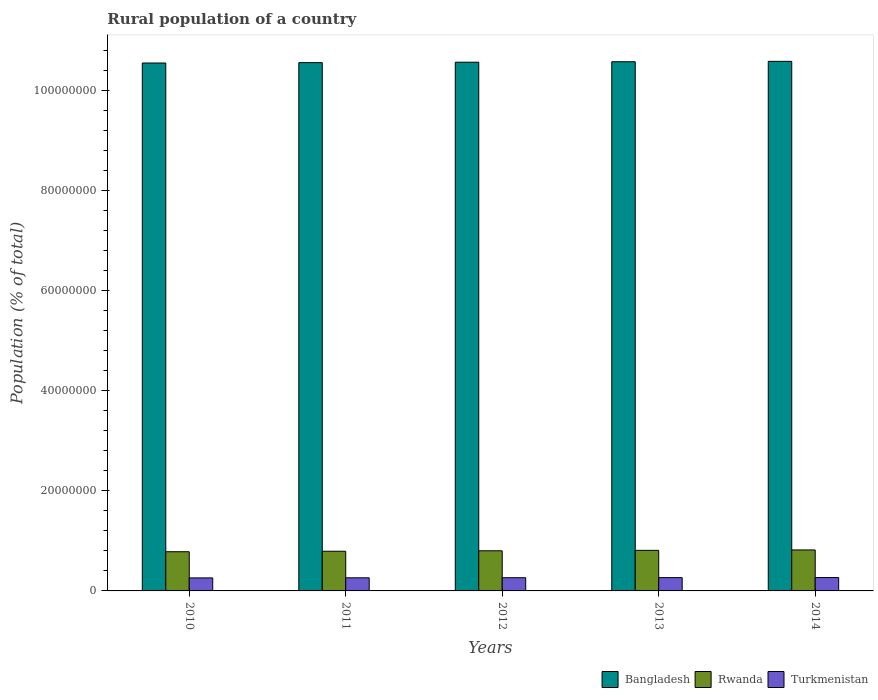How many different coloured bars are there?
Keep it short and to the point. 3. Are the number of bars per tick equal to the number of legend labels?
Your answer should be very brief. Yes. Are the number of bars on each tick of the X-axis equal?
Provide a succinct answer. Yes. How many bars are there on the 3rd tick from the left?
Give a very brief answer. 3. How many bars are there on the 1st tick from the right?
Provide a short and direct response. 3. What is the rural population in Turkmenistan in 2013?
Make the answer very short. 2.65e+06. Across all years, what is the maximum rural population in Turkmenistan?
Provide a short and direct response. 2.67e+06. Across all years, what is the minimum rural population in Bangladesh?
Ensure brevity in your answer.  1.05e+08. What is the total rural population in Bangladesh in the graph?
Offer a very short reply. 5.28e+08. What is the difference between the rural population in Bangladesh in 2010 and that in 2011?
Provide a short and direct response. -7.34e+04. What is the difference between the rural population in Bangladesh in 2011 and the rural population in Rwanda in 2013?
Your answer should be compact. 9.74e+07. What is the average rural population in Turkmenistan per year?
Your answer should be compact. 2.64e+06. In the year 2012, what is the difference between the rural population in Turkmenistan and rural population in Rwanda?
Give a very brief answer. -5.38e+06. In how many years, is the rural population in Turkmenistan greater than 48000000 %?
Your answer should be very brief. 0. What is the ratio of the rural population in Bangladesh in 2011 to that in 2012?
Keep it short and to the point. 1. Is the rural population in Rwanda in 2011 less than that in 2014?
Provide a short and direct response. Yes. What is the difference between the highest and the second highest rural population in Rwanda?
Offer a very short reply. 8.24e+04. What is the difference between the highest and the lowest rural population in Bangladesh?
Make the answer very short. 3.30e+05. What does the 1st bar from the left in 2013 represents?
Give a very brief answer. Bangladesh. What does the 1st bar from the right in 2012 represents?
Ensure brevity in your answer.  Turkmenistan. Is it the case that in every year, the sum of the rural population in Turkmenistan and rural population in Rwanda is greater than the rural population in Bangladesh?
Offer a very short reply. No. How many bars are there?
Offer a terse response. 15. How many years are there in the graph?
Your response must be concise. 5. What is the difference between two consecutive major ticks on the Y-axis?
Offer a terse response. 2.00e+07. Where does the legend appear in the graph?
Give a very brief answer. Bottom right. How are the legend labels stacked?
Offer a very short reply. Horizontal. What is the title of the graph?
Your answer should be very brief. Rural population of a country. Does "Pakistan" appear as one of the legend labels in the graph?
Ensure brevity in your answer.  No. What is the label or title of the Y-axis?
Your answer should be very brief. Population (% of total). What is the Population (% of total) of Bangladesh in 2010?
Provide a succinct answer. 1.05e+08. What is the Population (% of total) in Rwanda in 2010?
Provide a succinct answer. 7.83e+06. What is the Population (% of total) of Turkmenistan in 2010?
Offer a very short reply. 2.60e+06. What is the Population (% of total) of Bangladesh in 2011?
Your answer should be compact. 1.06e+08. What is the Population (% of total) of Rwanda in 2011?
Provide a short and direct response. 7.93e+06. What is the Population (% of total) in Turkmenistan in 2011?
Your response must be concise. 2.62e+06. What is the Population (% of total) of Bangladesh in 2012?
Ensure brevity in your answer.  1.06e+08. What is the Population (% of total) in Rwanda in 2012?
Your answer should be very brief. 8.02e+06. What is the Population (% of total) of Turkmenistan in 2012?
Offer a very short reply. 2.64e+06. What is the Population (% of total) in Bangladesh in 2013?
Your answer should be compact. 1.06e+08. What is the Population (% of total) in Rwanda in 2013?
Your answer should be compact. 8.10e+06. What is the Population (% of total) of Turkmenistan in 2013?
Offer a very short reply. 2.65e+06. What is the Population (% of total) in Bangladesh in 2014?
Make the answer very short. 1.06e+08. What is the Population (% of total) in Rwanda in 2014?
Keep it short and to the point. 8.18e+06. What is the Population (% of total) in Turkmenistan in 2014?
Ensure brevity in your answer.  2.67e+06. Across all years, what is the maximum Population (% of total) in Bangladesh?
Provide a short and direct response. 1.06e+08. Across all years, what is the maximum Population (% of total) in Rwanda?
Make the answer very short. 8.18e+06. Across all years, what is the maximum Population (% of total) of Turkmenistan?
Your answer should be very brief. 2.67e+06. Across all years, what is the minimum Population (% of total) of Bangladesh?
Your response must be concise. 1.05e+08. Across all years, what is the minimum Population (% of total) in Rwanda?
Your answer should be compact. 7.83e+06. Across all years, what is the minimum Population (% of total) of Turkmenistan?
Offer a terse response. 2.60e+06. What is the total Population (% of total) in Bangladesh in the graph?
Ensure brevity in your answer.  5.28e+08. What is the total Population (% of total) of Rwanda in the graph?
Offer a very short reply. 4.01e+07. What is the total Population (% of total) of Turkmenistan in the graph?
Make the answer very short. 1.32e+07. What is the difference between the Population (% of total) in Bangladesh in 2010 and that in 2011?
Your response must be concise. -7.34e+04. What is the difference between the Population (% of total) of Rwanda in 2010 and that in 2011?
Your response must be concise. -9.74e+04. What is the difference between the Population (% of total) of Turkmenistan in 2010 and that in 2011?
Your response must be concise. -1.78e+04. What is the difference between the Population (% of total) in Bangladesh in 2010 and that in 2012?
Offer a very short reply. -1.59e+05. What is the difference between the Population (% of total) of Rwanda in 2010 and that in 2012?
Your answer should be very brief. -1.88e+05. What is the difference between the Population (% of total) of Turkmenistan in 2010 and that in 2012?
Keep it short and to the point. -3.54e+04. What is the difference between the Population (% of total) of Bangladesh in 2010 and that in 2013?
Your answer should be very brief. -2.52e+05. What is the difference between the Population (% of total) of Rwanda in 2010 and that in 2013?
Keep it short and to the point. -2.73e+05. What is the difference between the Population (% of total) in Turkmenistan in 2010 and that in 2013?
Offer a terse response. -5.25e+04. What is the difference between the Population (% of total) of Bangladesh in 2010 and that in 2014?
Provide a succinct answer. -3.30e+05. What is the difference between the Population (% of total) of Rwanda in 2010 and that in 2014?
Give a very brief answer. -3.56e+05. What is the difference between the Population (% of total) in Turkmenistan in 2010 and that in 2014?
Provide a succinct answer. -6.86e+04. What is the difference between the Population (% of total) of Bangladesh in 2011 and that in 2012?
Ensure brevity in your answer.  -8.58e+04. What is the difference between the Population (% of total) of Rwanda in 2011 and that in 2012?
Provide a succinct answer. -9.07e+04. What is the difference between the Population (% of total) of Turkmenistan in 2011 and that in 2012?
Keep it short and to the point. -1.76e+04. What is the difference between the Population (% of total) in Bangladesh in 2011 and that in 2013?
Keep it short and to the point. -1.79e+05. What is the difference between the Population (% of total) in Rwanda in 2011 and that in 2013?
Ensure brevity in your answer.  -1.76e+05. What is the difference between the Population (% of total) in Turkmenistan in 2011 and that in 2013?
Your answer should be very brief. -3.47e+04. What is the difference between the Population (% of total) in Bangladesh in 2011 and that in 2014?
Provide a succinct answer. -2.56e+05. What is the difference between the Population (% of total) of Rwanda in 2011 and that in 2014?
Offer a terse response. -2.58e+05. What is the difference between the Population (% of total) in Turkmenistan in 2011 and that in 2014?
Your answer should be compact. -5.08e+04. What is the difference between the Population (% of total) of Bangladesh in 2012 and that in 2013?
Offer a terse response. -9.31e+04. What is the difference between the Population (% of total) in Rwanda in 2012 and that in 2013?
Make the answer very short. -8.52e+04. What is the difference between the Population (% of total) in Turkmenistan in 2012 and that in 2013?
Provide a succinct answer. -1.71e+04. What is the difference between the Population (% of total) of Bangladesh in 2012 and that in 2014?
Offer a terse response. -1.71e+05. What is the difference between the Population (% of total) of Rwanda in 2012 and that in 2014?
Your answer should be very brief. -1.68e+05. What is the difference between the Population (% of total) in Turkmenistan in 2012 and that in 2014?
Your response must be concise. -3.31e+04. What is the difference between the Population (% of total) in Bangladesh in 2013 and that in 2014?
Offer a terse response. -7.75e+04. What is the difference between the Population (% of total) in Rwanda in 2013 and that in 2014?
Ensure brevity in your answer.  -8.24e+04. What is the difference between the Population (% of total) in Turkmenistan in 2013 and that in 2014?
Your answer should be compact. -1.60e+04. What is the difference between the Population (% of total) in Bangladesh in 2010 and the Population (% of total) in Rwanda in 2011?
Your answer should be compact. 9.75e+07. What is the difference between the Population (% of total) in Bangladesh in 2010 and the Population (% of total) in Turkmenistan in 2011?
Give a very brief answer. 1.03e+08. What is the difference between the Population (% of total) in Rwanda in 2010 and the Population (% of total) in Turkmenistan in 2011?
Your answer should be very brief. 5.21e+06. What is the difference between the Population (% of total) in Bangladesh in 2010 and the Population (% of total) in Rwanda in 2012?
Your response must be concise. 9.74e+07. What is the difference between the Population (% of total) in Bangladesh in 2010 and the Population (% of total) in Turkmenistan in 2012?
Your response must be concise. 1.03e+08. What is the difference between the Population (% of total) of Rwanda in 2010 and the Population (% of total) of Turkmenistan in 2012?
Offer a very short reply. 5.19e+06. What is the difference between the Population (% of total) in Bangladesh in 2010 and the Population (% of total) in Rwanda in 2013?
Provide a succinct answer. 9.73e+07. What is the difference between the Population (% of total) in Bangladesh in 2010 and the Population (% of total) in Turkmenistan in 2013?
Offer a terse response. 1.03e+08. What is the difference between the Population (% of total) of Rwanda in 2010 and the Population (% of total) of Turkmenistan in 2013?
Make the answer very short. 5.17e+06. What is the difference between the Population (% of total) of Bangladesh in 2010 and the Population (% of total) of Rwanda in 2014?
Provide a succinct answer. 9.72e+07. What is the difference between the Population (% of total) of Bangladesh in 2010 and the Population (% of total) of Turkmenistan in 2014?
Keep it short and to the point. 1.03e+08. What is the difference between the Population (% of total) in Rwanda in 2010 and the Population (% of total) in Turkmenistan in 2014?
Your answer should be very brief. 5.16e+06. What is the difference between the Population (% of total) of Bangladesh in 2011 and the Population (% of total) of Rwanda in 2012?
Provide a succinct answer. 9.75e+07. What is the difference between the Population (% of total) of Bangladesh in 2011 and the Population (% of total) of Turkmenistan in 2012?
Offer a terse response. 1.03e+08. What is the difference between the Population (% of total) of Rwanda in 2011 and the Population (% of total) of Turkmenistan in 2012?
Provide a short and direct response. 5.29e+06. What is the difference between the Population (% of total) in Bangladesh in 2011 and the Population (% of total) in Rwanda in 2013?
Provide a succinct answer. 9.74e+07. What is the difference between the Population (% of total) of Bangladesh in 2011 and the Population (% of total) of Turkmenistan in 2013?
Make the answer very short. 1.03e+08. What is the difference between the Population (% of total) in Rwanda in 2011 and the Population (% of total) in Turkmenistan in 2013?
Provide a short and direct response. 5.27e+06. What is the difference between the Population (% of total) in Bangladesh in 2011 and the Population (% of total) in Rwanda in 2014?
Provide a short and direct response. 9.73e+07. What is the difference between the Population (% of total) of Bangladesh in 2011 and the Population (% of total) of Turkmenistan in 2014?
Your answer should be compact. 1.03e+08. What is the difference between the Population (% of total) of Rwanda in 2011 and the Population (% of total) of Turkmenistan in 2014?
Your response must be concise. 5.26e+06. What is the difference between the Population (% of total) of Bangladesh in 2012 and the Population (% of total) of Rwanda in 2013?
Provide a succinct answer. 9.75e+07. What is the difference between the Population (% of total) of Bangladesh in 2012 and the Population (% of total) of Turkmenistan in 2013?
Offer a very short reply. 1.03e+08. What is the difference between the Population (% of total) in Rwanda in 2012 and the Population (% of total) in Turkmenistan in 2013?
Ensure brevity in your answer.  5.36e+06. What is the difference between the Population (% of total) in Bangladesh in 2012 and the Population (% of total) in Rwanda in 2014?
Provide a short and direct response. 9.74e+07. What is the difference between the Population (% of total) in Bangladesh in 2012 and the Population (% of total) in Turkmenistan in 2014?
Keep it short and to the point. 1.03e+08. What is the difference between the Population (% of total) in Rwanda in 2012 and the Population (% of total) in Turkmenistan in 2014?
Provide a succinct answer. 5.35e+06. What is the difference between the Population (% of total) of Bangladesh in 2013 and the Population (% of total) of Rwanda in 2014?
Give a very brief answer. 9.75e+07. What is the difference between the Population (% of total) in Bangladesh in 2013 and the Population (% of total) in Turkmenistan in 2014?
Ensure brevity in your answer.  1.03e+08. What is the difference between the Population (% of total) in Rwanda in 2013 and the Population (% of total) in Turkmenistan in 2014?
Ensure brevity in your answer.  5.43e+06. What is the average Population (% of total) of Bangladesh per year?
Provide a succinct answer. 1.06e+08. What is the average Population (% of total) in Rwanda per year?
Give a very brief answer. 8.01e+06. What is the average Population (% of total) of Turkmenistan per year?
Your answer should be compact. 2.64e+06. In the year 2010, what is the difference between the Population (% of total) of Bangladesh and Population (% of total) of Rwanda?
Your answer should be very brief. 9.76e+07. In the year 2010, what is the difference between the Population (% of total) of Bangladesh and Population (% of total) of Turkmenistan?
Ensure brevity in your answer.  1.03e+08. In the year 2010, what is the difference between the Population (% of total) of Rwanda and Population (% of total) of Turkmenistan?
Ensure brevity in your answer.  5.23e+06. In the year 2011, what is the difference between the Population (% of total) in Bangladesh and Population (% of total) in Rwanda?
Provide a succinct answer. 9.76e+07. In the year 2011, what is the difference between the Population (% of total) of Bangladesh and Population (% of total) of Turkmenistan?
Provide a short and direct response. 1.03e+08. In the year 2011, what is the difference between the Population (% of total) of Rwanda and Population (% of total) of Turkmenistan?
Give a very brief answer. 5.31e+06. In the year 2012, what is the difference between the Population (% of total) of Bangladesh and Population (% of total) of Rwanda?
Provide a short and direct response. 9.76e+07. In the year 2012, what is the difference between the Population (% of total) in Bangladesh and Population (% of total) in Turkmenistan?
Your response must be concise. 1.03e+08. In the year 2012, what is the difference between the Population (% of total) of Rwanda and Population (% of total) of Turkmenistan?
Provide a succinct answer. 5.38e+06. In the year 2013, what is the difference between the Population (% of total) of Bangladesh and Population (% of total) of Rwanda?
Keep it short and to the point. 9.76e+07. In the year 2013, what is the difference between the Population (% of total) in Bangladesh and Population (% of total) in Turkmenistan?
Provide a succinct answer. 1.03e+08. In the year 2013, what is the difference between the Population (% of total) in Rwanda and Population (% of total) in Turkmenistan?
Provide a succinct answer. 5.45e+06. In the year 2014, what is the difference between the Population (% of total) of Bangladesh and Population (% of total) of Rwanda?
Make the answer very short. 9.76e+07. In the year 2014, what is the difference between the Population (% of total) in Bangladesh and Population (% of total) in Turkmenistan?
Provide a short and direct response. 1.03e+08. In the year 2014, what is the difference between the Population (% of total) in Rwanda and Population (% of total) in Turkmenistan?
Keep it short and to the point. 5.51e+06. What is the ratio of the Population (% of total) of Bangladesh in 2010 to that in 2011?
Keep it short and to the point. 1. What is the ratio of the Population (% of total) in Rwanda in 2010 to that in 2011?
Give a very brief answer. 0.99. What is the ratio of the Population (% of total) of Rwanda in 2010 to that in 2012?
Keep it short and to the point. 0.98. What is the ratio of the Population (% of total) in Turkmenistan in 2010 to that in 2012?
Give a very brief answer. 0.99. What is the ratio of the Population (% of total) of Bangladesh in 2010 to that in 2013?
Give a very brief answer. 1. What is the ratio of the Population (% of total) of Rwanda in 2010 to that in 2013?
Offer a terse response. 0.97. What is the ratio of the Population (% of total) of Turkmenistan in 2010 to that in 2013?
Offer a terse response. 0.98. What is the ratio of the Population (% of total) of Bangladesh in 2010 to that in 2014?
Offer a terse response. 1. What is the ratio of the Population (% of total) of Rwanda in 2010 to that in 2014?
Your answer should be very brief. 0.96. What is the ratio of the Population (% of total) of Turkmenistan in 2010 to that in 2014?
Offer a very short reply. 0.97. What is the ratio of the Population (% of total) of Bangladesh in 2011 to that in 2012?
Give a very brief answer. 1. What is the ratio of the Population (% of total) in Rwanda in 2011 to that in 2012?
Provide a succinct answer. 0.99. What is the ratio of the Population (% of total) in Bangladesh in 2011 to that in 2013?
Provide a succinct answer. 1. What is the ratio of the Population (% of total) in Rwanda in 2011 to that in 2013?
Make the answer very short. 0.98. What is the ratio of the Population (% of total) of Turkmenistan in 2011 to that in 2013?
Offer a terse response. 0.99. What is the ratio of the Population (% of total) of Rwanda in 2011 to that in 2014?
Ensure brevity in your answer.  0.97. What is the ratio of the Population (% of total) in Rwanda in 2012 to that in 2013?
Provide a short and direct response. 0.99. What is the ratio of the Population (% of total) in Turkmenistan in 2012 to that in 2013?
Your answer should be compact. 0.99. What is the ratio of the Population (% of total) in Bangladesh in 2012 to that in 2014?
Offer a terse response. 1. What is the ratio of the Population (% of total) in Rwanda in 2012 to that in 2014?
Your answer should be compact. 0.98. What is the ratio of the Population (% of total) in Turkmenistan in 2012 to that in 2014?
Keep it short and to the point. 0.99. What is the ratio of the Population (% of total) in Turkmenistan in 2013 to that in 2014?
Offer a terse response. 0.99. What is the difference between the highest and the second highest Population (% of total) of Bangladesh?
Keep it short and to the point. 7.75e+04. What is the difference between the highest and the second highest Population (% of total) in Rwanda?
Ensure brevity in your answer.  8.24e+04. What is the difference between the highest and the second highest Population (% of total) of Turkmenistan?
Provide a short and direct response. 1.60e+04. What is the difference between the highest and the lowest Population (% of total) in Bangladesh?
Keep it short and to the point. 3.30e+05. What is the difference between the highest and the lowest Population (% of total) of Rwanda?
Offer a very short reply. 3.56e+05. What is the difference between the highest and the lowest Population (% of total) in Turkmenistan?
Provide a short and direct response. 6.86e+04. 